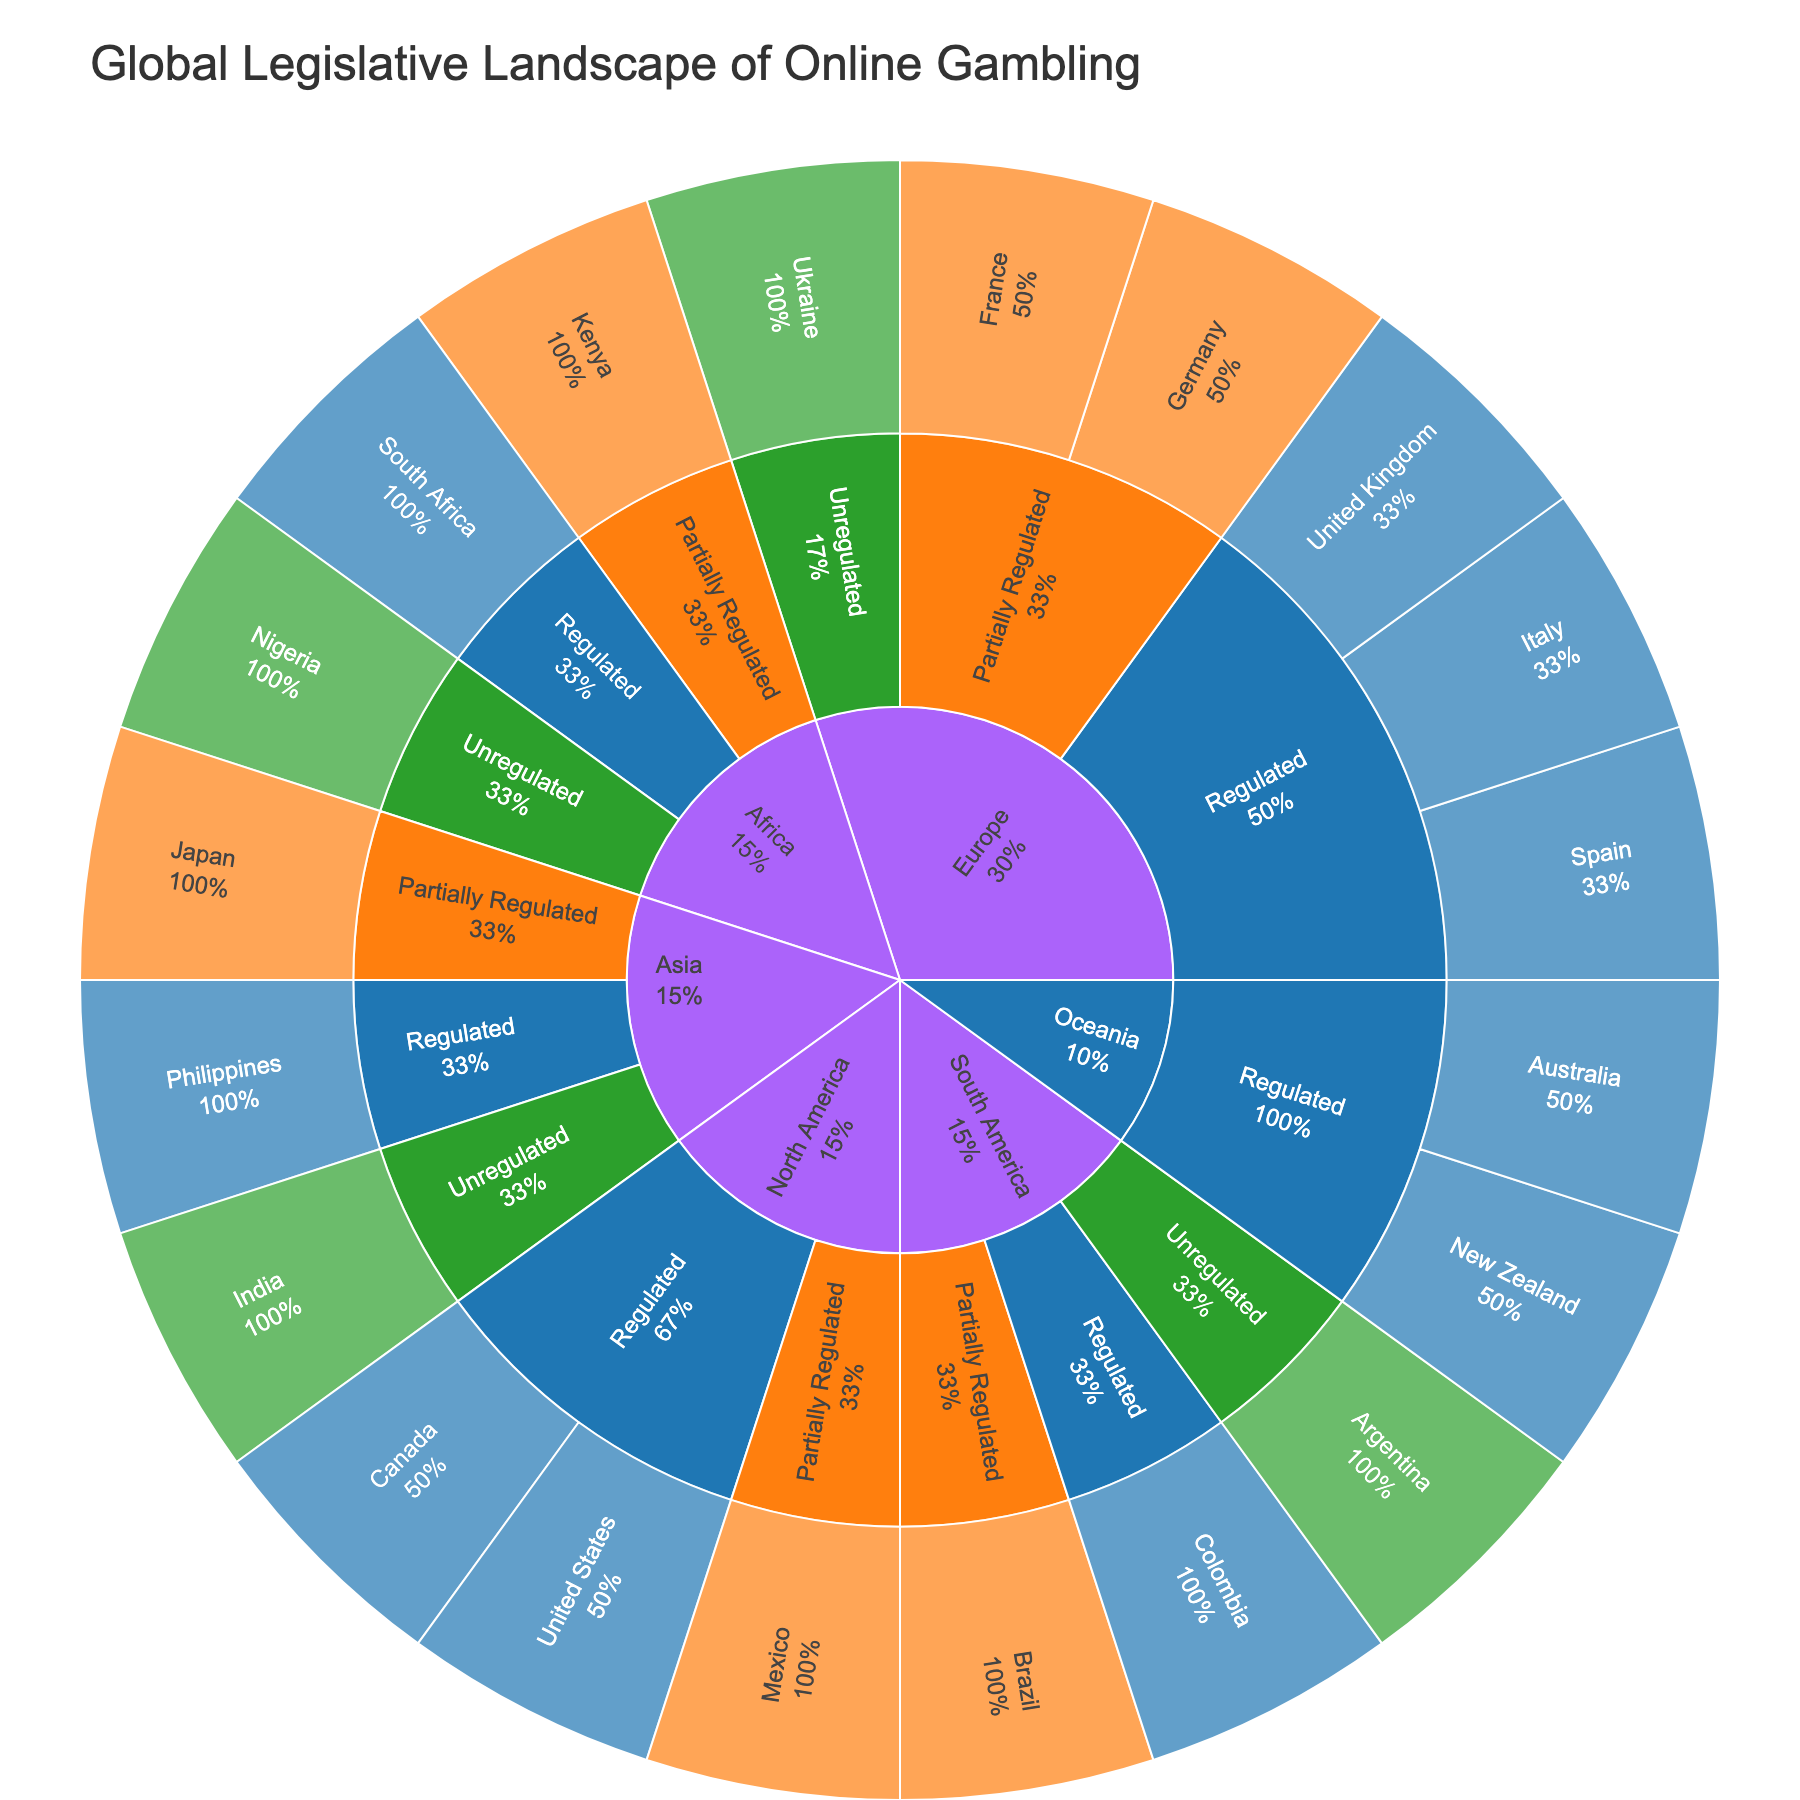What is the title of the Sunburst Plot? The title is usually located at the top of the plot and clearly indicates the subject of the data. We are told it is "Global Legislative Landscape of Online Gambling".
Answer: Global Legislative Landscape of Online Gambling What are the different regulatory approaches shown in the plot? The plot uses specific colors to differentiate between the regulatory approaches. The colors represent 'Regulated', 'Partially Regulated', and 'Unregulated'.
Answer: Regulated, Partially Regulated, Unregulated Which region has the most countries with a 'Regulated' approach? By counting the segments under 'Regulated' for each region, Europe has the highest number of countries with a regulated approach.
Answer: Europe How many countries in Asia have a 'Partially Regulated' approach? By examining the 'Partially Regulated' section under the Asia region, we see there is only one country, Japan.
Answer: 1 How is the United States categorized in terms of regulatory approach, and what specific legislation is mentioned? The United States is located under North America and falls under the 'Regulated' category, with the specific legislation being UIGEA.
Answer: Regulated, UIGEA Which regions have countries labeled as 'Unregulated,' and how many countries does each region have this label? Count the countries under 'Unregulated' for the regions. Europe, South America, Asia, and Africa have countries labeled as 'Unregulated'. Europe has 1 (Ukraine), South America has 1 (Argentina), Asia has 1 (India), and Africa has 1 (Nigeria).
Answer: Europe: 1, South America: 1, Asia: 1, Africa: 1 Compare the number of countries in North America with a 'Regulated' approach to those in South America with the same approach. North America has 2 countries (United States, Canada) with a 'Regulated' approach, while South America has 1 country (Colombia).
Answer: North America: 2, South America: 1 What specific legislation is cited for the Philippines under the 'Regulated' category in Asia? By locating the Philippines in the 'Regulated' section under Asia, the specific legislation cited is PAGCOR Act.
Answer: PAGCOR Act How many regions have a 'Partially Regulated' approach, and can you list them? Count the regions with visible segments under the 'Partially Regulated' category. Four regions (Europe, North America, South America, Africa) have this approach: Europe, North America, South America, and Africa.
Answer: 4: Europe, North America, South America, Africa 